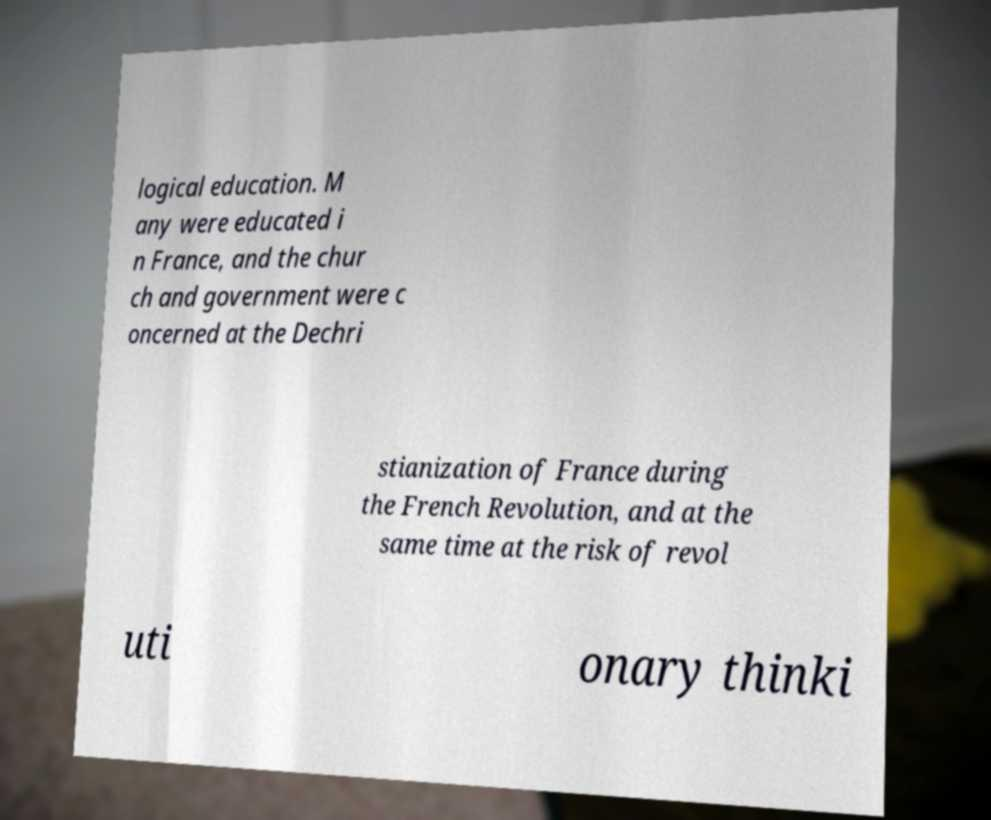Could you assist in decoding the text presented in this image and type it out clearly? logical education. M any were educated i n France, and the chur ch and government were c oncerned at the Dechri stianization of France during the French Revolution, and at the same time at the risk of revol uti onary thinki 